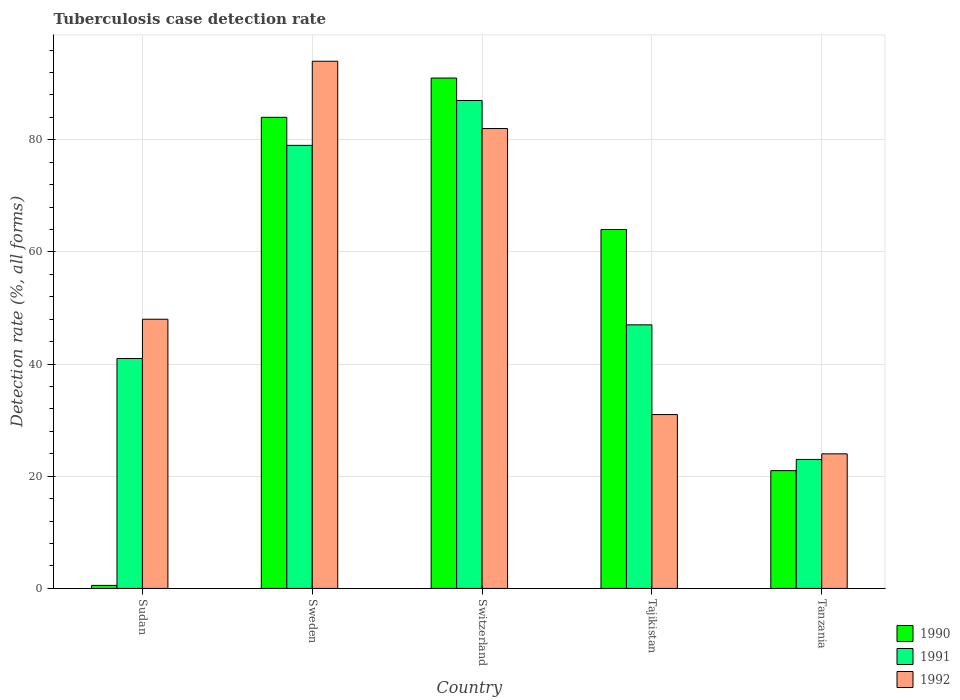Are the number of bars per tick equal to the number of legend labels?
Ensure brevity in your answer.  Yes. Are the number of bars on each tick of the X-axis equal?
Provide a short and direct response. Yes. How many bars are there on the 5th tick from the right?
Provide a short and direct response. 3. What is the label of the 4th group of bars from the left?
Provide a succinct answer. Tajikistan. In how many cases, is the number of bars for a given country not equal to the number of legend labels?
Ensure brevity in your answer.  0. Across all countries, what is the maximum tuberculosis case detection rate in in 1991?
Keep it short and to the point. 87. In which country was the tuberculosis case detection rate in in 1990 maximum?
Ensure brevity in your answer.  Switzerland. In which country was the tuberculosis case detection rate in in 1992 minimum?
Provide a succinct answer. Tanzania. What is the total tuberculosis case detection rate in in 1990 in the graph?
Make the answer very short. 260.54. What is the average tuberculosis case detection rate in in 1991 per country?
Offer a terse response. 55.4. What is the difference between the tuberculosis case detection rate in of/in 1991 and tuberculosis case detection rate in of/in 1990 in Tanzania?
Make the answer very short. 2. What is the ratio of the tuberculosis case detection rate in in 1990 in Switzerland to that in Tanzania?
Your answer should be very brief. 4.33. Is the tuberculosis case detection rate in in 1992 in Switzerland less than that in Tajikistan?
Offer a terse response. No. What is the difference between the highest and the lowest tuberculosis case detection rate in in 1990?
Your answer should be compact. 90.46. What does the 1st bar from the right in Sweden represents?
Offer a very short reply. 1992. Is it the case that in every country, the sum of the tuberculosis case detection rate in in 1992 and tuberculosis case detection rate in in 1991 is greater than the tuberculosis case detection rate in in 1990?
Ensure brevity in your answer.  Yes. How many bars are there?
Offer a very short reply. 15. Are all the bars in the graph horizontal?
Provide a succinct answer. No. How many countries are there in the graph?
Provide a short and direct response. 5. What is the difference between two consecutive major ticks on the Y-axis?
Your answer should be compact. 20. Where does the legend appear in the graph?
Provide a succinct answer. Bottom right. What is the title of the graph?
Provide a short and direct response. Tuberculosis case detection rate. Does "1997" appear as one of the legend labels in the graph?
Your answer should be very brief. No. What is the label or title of the Y-axis?
Provide a succinct answer. Detection rate (%, all forms). What is the Detection rate (%, all forms) in 1990 in Sudan?
Your response must be concise. 0.54. What is the Detection rate (%, all forms) of 1990 in Sweden?
Offer a very short reply. 84. What is the Detection rate (%, all forms) in 1991 in Sweden?
Your answer should be very brief. 79. What is the Detection rate (%, all forms) in 1992 in Sweden?
Offer a terse response. 94. What is the Detection rate (%, all forms) in 1990 in Switzerland?
Give a very brief answer. 91. What is the Detection rate (%, all forms) in 1990 in Tajikistan?
Your answer should be compact. 64. What is the Detection rate (%, all forms) of 1991 in Tajikistan?
Make the answer very short. 47. What is the Detection rate (%, all forms) in 1992 in Tajikistan?
Offer a terse response. 31. Across all countries, what is the maximum Detection rate (%, all forms) of 1990?
Keep it short and to the point. 91. Across all countries, what is the maximum Detection rate (%, all forms) in 1992?
Your answer should be compact. 94. Across all countries, what is the minimum Detection rate (%, all forms) in 1990?
Give a very brief answer. 0.54. What is the total Detection rate (%, all forms) in 1990 in the graph?
Your response must be concise. 260.54. What is the total Detection rate (%, all forms) in 1991 in the graph?
Keep it short and to the point. 277. What is the total Detection rate (%, all forms) in 1992 in the graph?
Give a very brief answer. 279. What is the difference between the Detection rate (%, all forms) in 1990 in Sudan and that in Sweden?
Provide a short and direct response. -83.46. What is the difference between the Detection rate (%, all forms) of 1991 in Sudan and that in Sweden?
Make the answer very short. -38. What is the difference between the Detection rate (%, all forms) of 1992 in Sudan and that in Sweden?
Offer a terse response. -46. What is the difference between the Detection rate (%, all forms) of 1990 in Sudan and that in Switzerland?
Ensure brevity in your answer.  -90.46. What is the difference between the Detection rate (%, all forms) of 1991 in Sudan and that in Switzerland?
Ensure brevity in your answer.  -46. What is the difference between the Detection rate (%, all forms) in 1992 in Sudan and that in Switzerland?
Your answer should be very brief. -34. What is the difference between the Detection rate (%, all forms) of 1990 in Sudan and that in Tajikistan?
Offer a terse response. -63.46. What is the difference between the Detection rate (%, all forms) of 1990 in Sudan and that in Tanzania?
Ensure brevity in your answer.  -20.46. What is the difference between the Detection rate (%, all forms) in 1991 in Sudan and that in Tanzania?
Make the answer very short. 18. What is the difference between the Detection rate (%, all forms) of 1990 in Sweden and that in Switzerland?
Offer a very short reply. -7. What is the difference between the Detection rate (%, all forms) in 1991 in Sweden and that in Switzerland?
Offer a terse response. -8. What is the difference between the Detection rate (%, all forms) of 1990 in Sweden and that in Tajikistan?
Provide a succinct answer. 20. What is the difference between the Detection rate (%, all forms) in 1992 in Sweden and that in Tajikistan?
Offer a very short reply. 63. What is the difference between the Detection rate (%, all forms) in 1992 in Sweden and that in Tanzania?
Keep it short and to the point. 70. What is the difference between the Detection rate (%, all forms) of 1990 in Switzerland and that in Tajikistan?
Your answer should be compact. 27. What is the difference between the Detection rate (%, all forms) in 1991 in Switzerland and that in Tajikistan?
Your answer should be very brief. 40. What is the difference between the Detection rate (%, all forms) of 1990 in Tajikistan and that in Tanzania?
Give a very brief answer. 43. What is the difference between the Detection rate (%, all forms) in 1992 in Tajikistan and that in Tanzania?
Provide a short and direct response. 7. What is the difference between the Detection rate (%, all forms) of 1990 in Sudan and the Detection rate (%, all forms) of 1991 in Sweden?
Keep it short and to the point. -78.46. What is the difference between the Detection rate (%, all forms) in 1990 in Sudan and the Detection rate (%, all forms) in 1992 in Sweden?
Make the answer very short. -93.46. What is the difference between the Detection rate (%, all forms) of 1991 in Sudan and the Detection rate (%, all forms) of 1992 in Sweden?
Keep it short and to the point. -53. What is the difference between the Detection rate (%, all forms) in 1990 in Sudan and the Detection rate (%, all forms) in 1991 in Switzerland?
Offer a terse response. -86.46. What is the difference between the Detection rate (%, all forms) in 1990 in Sudan and the Detection rate (%, all forms) in 1992 in Switzerland?
Ensure brevity in your answer.  -81.46. What is the difference between the Detection rate (%, all forms) in 1991 in Sudan and the Detection rate (%, all forms) in 1992 in Switzerland?
Keep it short and to the point. -41. What is the difference between the Detection rate (%, all forms) of 1990 in Sudan and the Detection rate (%, all forms) of 1991 in Tajikistan?
Your response must be concise. -46.46. What is the difference between the Detection rate (%, all forms) of 1990 in Sudan and the Detection rate (%, all forms) of 1992 in Tajikistan?
Provide a short and direct response. -30.46. What is the difference between the Detection rate (%, all forms) of 1991 in Sudan and the Detection rate (%, all forms) of 1992 in Tajikistan?
Make the answer very short. 10. What is the difference between the Detection rate (%, all forms) in 1990 in Sudan and the Detection rate (%, all forms) in 1991 in Tanzania?
Your answer should be compact. -22.46. What is the difference between the Detection rate (%, all forms) in 1990 in Sudan and the Detection rate (%, all forms) in 1992 in Tanzania?
Ensure brevity in your answer.  -23.46. What is the difference between the Detection rate (%, all forms) in 1991 in Sudan and the Detection rate (%, all forms) in 1992 in Tanzania?
Provide a short and direct response. 17. What is the difference between the Detection rate (%, all forms) of 1990 in Sweden and the Detection rate (%, all forms) of 1991 in Switzerland?
Make the answer very short. -3. What is the difference between the Detection rate (%, all forms) in 1990 in Sweden and the Detection rate (%, all forms) in 1992 in Switzerland?
Your answer should be very brief. 2. What is the difference between the Detection rate (%, all forms) of 1991 in Sweden and the Detection rate (%, all forms) of 1992 in Switzerland?
Your answer should be very brief. -3. What is the difference between the Detection rate (%, all forms) of 1990 in Sweden and the Detection rate (%, all forms) of 1992 in Tajikistan?
Your answer should be very brief. 53. What is the difference between the Detection rate (%, all forms) in 1991 in Sweden and the Detection rate (%, all forms) in 1992 in Tajikistan?
Keep it short and to the point. 48. What is the difference between the Detection rate (%, all forms) in 1990 in Switzerland and the Detection rate (%, all forms) in 1992 in Tajikistan?
Offer a terse response. 60. What is the difference between the Detection rate (%, all forms) of 1991 in Switzerland and the Detection rate (%, all forms) of 1992 in Tajikistan?
Your answer should be compact. 56. What is the difference between the Detection rate (%, all forms) in 1990 in Switzerland and the Detection rate (%, all forms) in 1991 in Tanzania?
Your answer should be very brief. 68. What is the difference between the Detection rate (%, all forms) of 1990 in Switzerland and the Detection rate (%, all forms) of 1992 in Tanzania?
Make the answer very short. 67. What is the difference between the Detection rate (%, all forms) in 1991 in Switzerland and the Detection rate (%, all forms) in 1992 in Tanzania?
Make the answer very short. 63. What is the difference between the Detection rate (%, all forms) in 1990 in Tajikistan and the Detection rate (%, all forms) in 1991 in Tanzania?
Your answer should be compact. 41. What is the difference between the Detection rate (%, all forms) of 1990 in Tajikistan and the Detection rate (%, all forms) of 1992 in Tanzania?
Make the answer very short. 40. What is the difference between the Detection rate (%, all forms) of 1991 in Tajikistan and the Detection rate (%, all forms) of 1992 in Tanzania?
Your response must be concise. 23. What is the average Detection rate (%, all forms) in 1990 per country?
Make the answer very short. 52.11. What is the average Detection rate (%, all forms) in 1991 per country?
Keep it short and to the point. 55.4. What is the average Detection rate (%, all forms) in 1992 per country?
Provide a succinct answer. 55.8. What is the difference between the Detection rate (%, all forms) of 1990 and Detection rate (%, all forms) of 1991 in Sudan?
Your answer should be compact. -40.46. What is the difference between the Detection rate (%, all forms) of 1990 and Detection rate (%, all forms) of 1992 in Sudan?
Keep it short and to the point. -47.46. What is the difference between the Detection rate (%, all forms) in 1991 and Detection rate (%, all forms) in 1992 in Sudan?
Ensure brevity in your answer.  -7. What is the difference between the Detection rate (%, all forms) of 1990 and Detection rate (%, all forms) of 1991 in Sweden?
Offer a terse response. 5. What is the difference between the Detection rate (%, all forms) of 1991 and Detection rate (%, all forms) of 1992 in Sweden?
Your answer should be very brief. -15. What is the difference between the Detection rate (%, all forms) of 1990 and Detection rate (%, all forms) of 1991 in Switzerland?
Provide a succinct answer. 4. What is the difference between the Detection rate (%, all forms) in 1990 and Detection rate (%, all forms) in 1992 in Switzerland?
Your answer should be very brief. 9. What is the difference between the Detection rate (%, all forms) in 1991 and Detection rate (%, all forms) in 1992 in Tanzania?
Your answer should be compact. -1. What is the ratio of the Detection rate (%, all forms) in 1990 in Sudan to that in Sweden?
Provide a short and direct response. 0.01. What is the ratio of the Detection rate (%, all forms) of 1991 in Sudan to that in Sweden?
Your response must be concise. 0.52. What is the ratio of the Detection rate (%, all forms) in 1992 in Sudan to that in Sweden?
Keep it short and to the point. 0.51. What is the ratio of the Detection rate (%, all forms) in 1990 in Sudan to that in Switzerland?
Your answer should be compact. 0.01. What is the ratio of the Detection rate (%, all forms) of 1991 in Sudan to that in Switzerland?
Your response must be concise. 0.47. What is the ratio of the Detection rate (%, all forms) of 1992 in Sudan to that in Switzerland?
Your response must be concise. 0.59. What is the ratio of the Detection rate (%, all forms) in 1990 in Sudan to that in Tajikistan?
Provide a succinct answer. 0.01. What is the ratio of the Detection rate (%, all forms) of 1991 in Sudan to that in Tajikistan?
Provide a succinct answer. 0.87. What is the ratio of the Detection rate (%, all forms) of 1992 in Sudan to that in Tajikistan?
Your answer should be very brief. 1.55. What is the ratio of the Detection rate (%, all forms) of 1990 in Sudan to that in Tanzania?
Your answer should be compact. 0.03. What is the ratio of the Detection rate (%, all forms) in 1991 in Sudan to that in Tanzania?
Your answer should be very brief. 1.78. What is the ratio of the Detection rate (%, all forms) in 1990 in Sweden to that in Switzerland?
Provide a succinct answer. 0.92. What is the ratio of the Detection rate (%, all forms) of 1991 in Sweden to that in Switzerland?
Your response must be concise. 0.91. What is the ratio of the Detection rate (%, all forms) in 1992 in Sweden to that in Switzerland?
Provide a succinct answer. 1.15. What is the ratio of the Detection rate (%, all forms) of 1990 in Sweden to that in Tajikistan?
Your answer should be compact. 1.31. What is the ratio of the Detection rate (%, all forms) in 1991 in Sweden to that in Tajikistan?
Offer a terse response. 1.68. What is the ratio of the Detection rate (%, all forms) of 1992 in Sweden to that in Tajikistan?
Your response must be concise. 3.03. What is the ratio of the Detection rate (%, all forms) of 1991 in Sweden to that in Tanzania?
Offer a very short reply. 3.43. What is the ratio of the Detection rate (%, all forms) in 1992 in Sweden to that in Tanzania?
Give a very brief answer. 3.92. What is the ratio of the Detection rate (%, all forms) of 1990 in Switzerland to that in Tajikistan?
Offer a terse response. 1.42. What is the ratio of the Detection rate (%, all forms) of 1991 in Switzerland to that in Tajikistan?
Your answer should be compact. 1.85. What is the ratio of the Detection rate (%, all forms) of 1992 in Switzerland to that in Tajikistan?
Give a very brief answer. 2.65. What is the ratio of the Detection rate (%, all forms) in 1990 in Switzerland to that in Tanzania?
Ensure brevity in your answer.  4.33. What is the ratio of the Detection rate (%, all forms) of 1991 in Switzerland to that in Tanzania?
Ensure brevity in your answer.  3.78. What is the ratio of the Detection rate (%, all forms) of 1992 in Switzerland to that in Tanzania?
Make the answer very short. 3.42. What is the ratio of the Detection rate (%, all forms) of 1990 in Tajikistan to that in Tanzania?
Your answer should be very brief. 3.05. What is the ratio of the Detection rate (%, all forms) of 1991 in Tajikistan to that in Tanzania?
Provide a short and direct response. 2.04. What is the ratio of the Detection rate (%, all forms) of 1992 in Tajikistan to that in Tanzania?
Provide a short and direct response. 1.29. What is the difference between the highest and the second highest Detection rate (%, all forms) of 1991?
Give a very brief answer. 8. What is the difference between the highest and the lowest Detection rate (%, all forms) in 1990?
Provide a short and direct response. 90.46. 